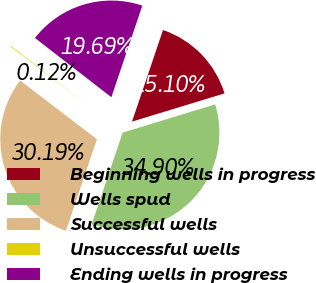<chart> <loc_0><loc_0><loc_500><loc_500><pie_chart><fcel>Beginning wells in progress<fcel>Wells spud<fcel>Successful wells<fcel>Unsuccessful wells<fcel>Ending wells in progress<nl><fcel>15.1%<fcel>34.9%<fcel>30.19%<fcel>0.12%<fcel>19.69%<nl></chart> 